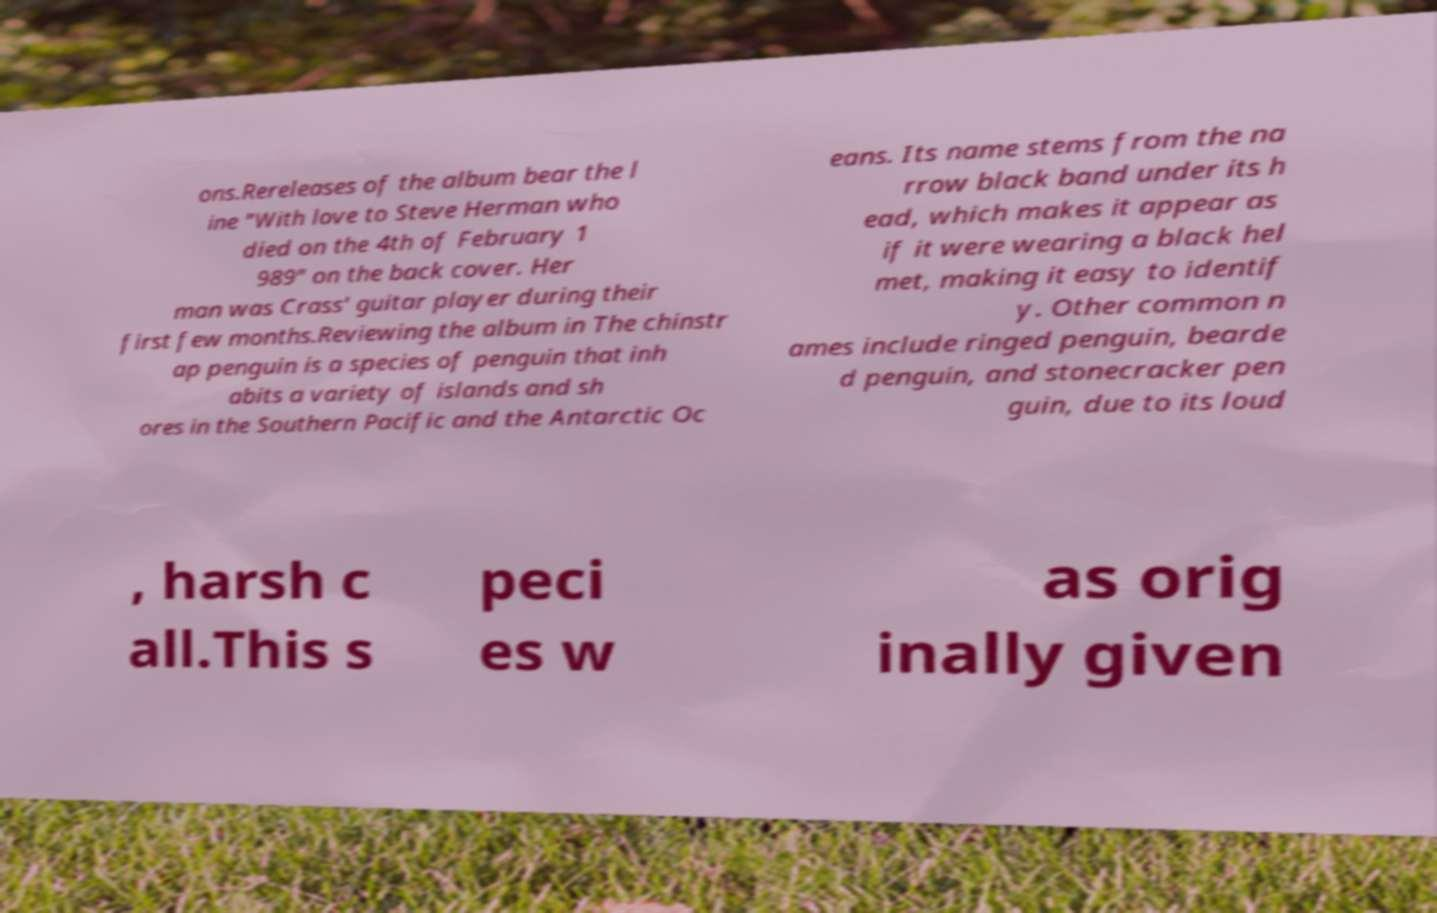Can you read and provide the text displayed in the image?This photo seems to have some interesting text. Can you extract and type it out for me? ons.Rereleases of the album bear the l ine "With love to Steve Herman who died on the 4th of February 1 989" on the back cover. Her man was Crass' guitar player during their first few months.Reviewing the album in The chinstr ap penguin is a species of penguin that inh abits a variety of islands and sh ores in the Southern Pacific and the Antarctic Oc eans. Its name stems from the na rrow black band under its h ead, which makes it appear as if it were wearing a black hel met, making it easy to identif y. Other common n ames include ringed penguin, bearde d penguin, and stonecracker pen guin, due to its loud , harsh c all.This s peci es w as orig inally given 